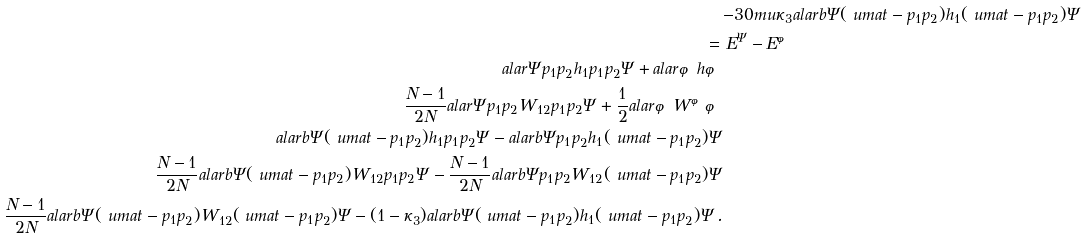<formula> <loc_0><loc_0><loc_500><loc_500>& { - 3 0 m u } \kappa _ { 3 } a l a r b { \Psi } { ( \ u m a t - p _ { 1 } p _ { 2 } ) h _ { 1 } ( \ u m a t - p _ { 1 } p _ { 2 } ) \Psi } \\ \, = \, & \, E ^ { \Psi } - E ^ { \varphi } \\ a l a r { \Psi } { p _ { 1 } p _ { 2 } h _ { 1 } p _ { 1 } p _ { 2 } \Psi } + a l a r { \varphi } { h \varphi } \\ \frac { N - 1 } { 2 N } a l a r { \Psi } { p _ { 1 } p _ { 2 } W _ { 1 2 } p _ { 1 } p _ { 2 } \Psi } + \frac { 1 } { 2 } a l a r { \varphi } { W ^ { \varphi } \varphi } \\ a l a r b { \Psi } { ( \ u m a t - p _ { 1 } p _ { 2 } ) h _ { 1 } p _ { 1 } p _ { 2 } \Psi } - a l a r b { \Psi } { p _ { 1 } p _ { 2 } h _ { 1 } ( \ u m a t - p _ { 1 } p _ { 2 } ) \Psi } \\ \frac { N - 1 } { 2 N } a l a r b { \Psi } { ( \ u m a t - p _ { 1 } p _ { 2 } ) W _ { 1 2 } p _ { 1 } p _ { 2 } \Psi } - \frac { N - 1 } { 2 N } a l a r b { \Psi } { p _ { 1 } p _ { 2 } W _ { 1 2 } ( \ u m a t - p _ { 1 } p _ { 2 } ) \Psi } \\ \frac { N - 1 } { 2 N } a l a r b { \Psi } { ( \ u m a t - p _ { 1 } p _ { 2 } ) W _ { 1 2 } ( \ u m a t - p _ { 1 } p _ { 2 } ) \Psi } - ( 1 - \kappa _ { 3 } ) a l a r b { \Psi } { ( \ u m a t - p _ { 1 } p _ { 2 } ) h _ { 1 } ( \ u m a t - p _ { 1 } p _ { 2 } ) \Psi } \, .</formula> 